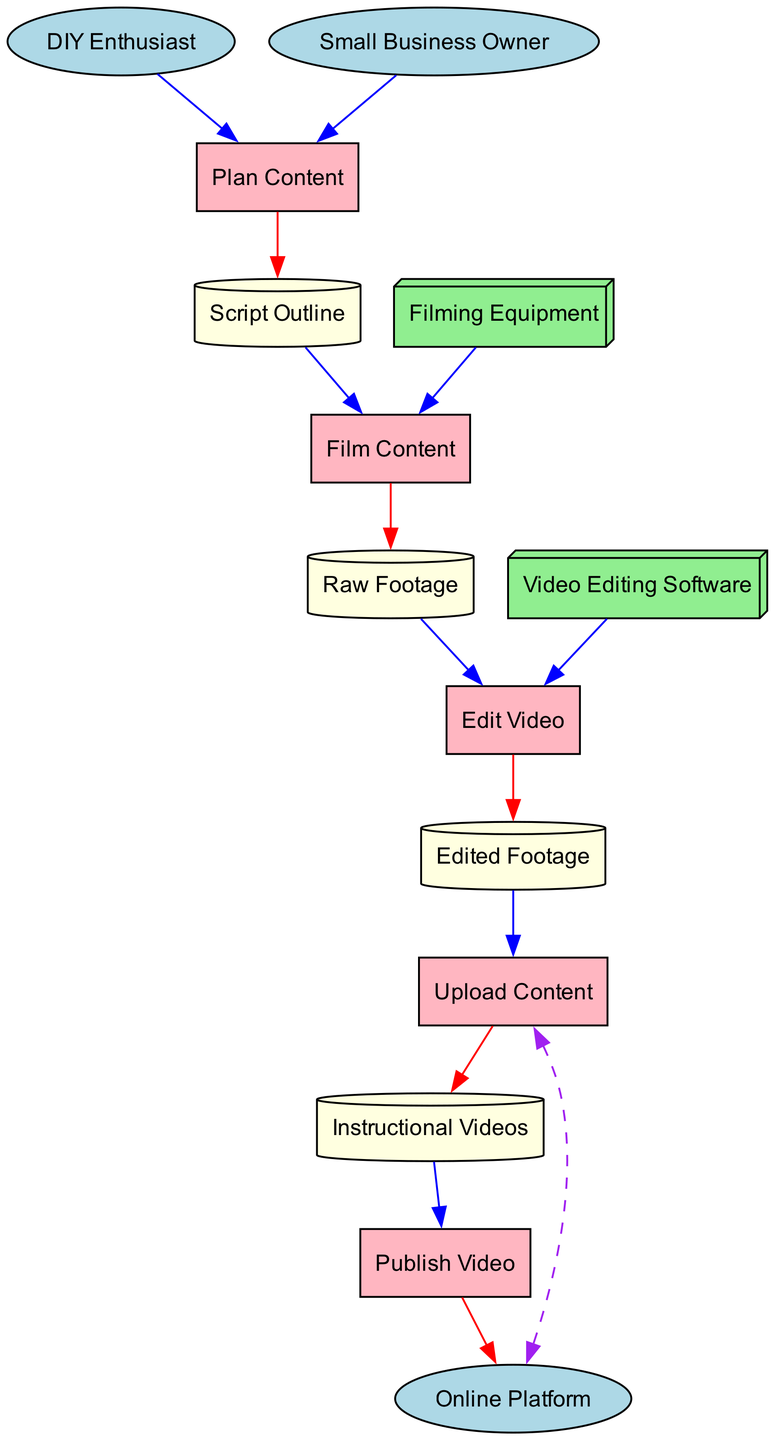What are the two external entities in the diagram? The diagram displays two external entities: the DIY Enthusiast and the Small Business Owner. These are clearly marked as external entities and listed at the start of the entities section.
Answer: DIY Enthusiast, Small Business Owner How many data stores are represented in the diagram? The diagram includes four data stores: Raw Footage, Edited Footage, Instructional Videos, and Script Outline. By counting these data stores in the entities section, we find there are four.
Answer: Four What is the output of the "Plan Content" process? The "Plan Content" process has a defined output which is the Script Outline. This is indicated in the outputs section of this process.
Answer: Script Outline Which process uses Filming Equipment as an input? The process that uses Filming Equipment as input is "Film Content". By reviewing the inputs listed for each process, we can identify that Filming Equipment is specifically required for the "Film Content" process.
Answer: Film Content What is the final output in the data flow? The final output in the data flow is the Online Platform. The last process depicted, "Publish Video", shows it outputs to the Online Platform, indicating this is where the instructional videos end up.
Answer: Online Platform How many processes are listed in the diagram? The diagram outlines five processes: Plan Content, Film Content, Edit Video, Upload Content, and Publish Video. Counting each of them reveals that there are five distinct processes.
Answer: Five What interaction type exists between the "Upload Content" process and the "Online Platform"? The interaction type between the "Upload Content" process and the "Online Platform" is defined as a dashed arrow. This indicates a bidirectional interaction, which is shown in the interaction section of the relevant process.
Answer: Dashed What is the input for the "Edit Video" process? The input for the "Edit Video" process is the Raw Footage, as stated in the inputs section of this process. By checking the input listings, it's clear that Raw Footage is necessary for editing.
Answer: Raw Footage Which process comes after "Edit Video"? The "Upload Content" process follows the "Edit Video" process in the workflow. By reviewing the order of processes as described, we can see that Upload Content is directly after Edit Video.
Answer: Upload Content 